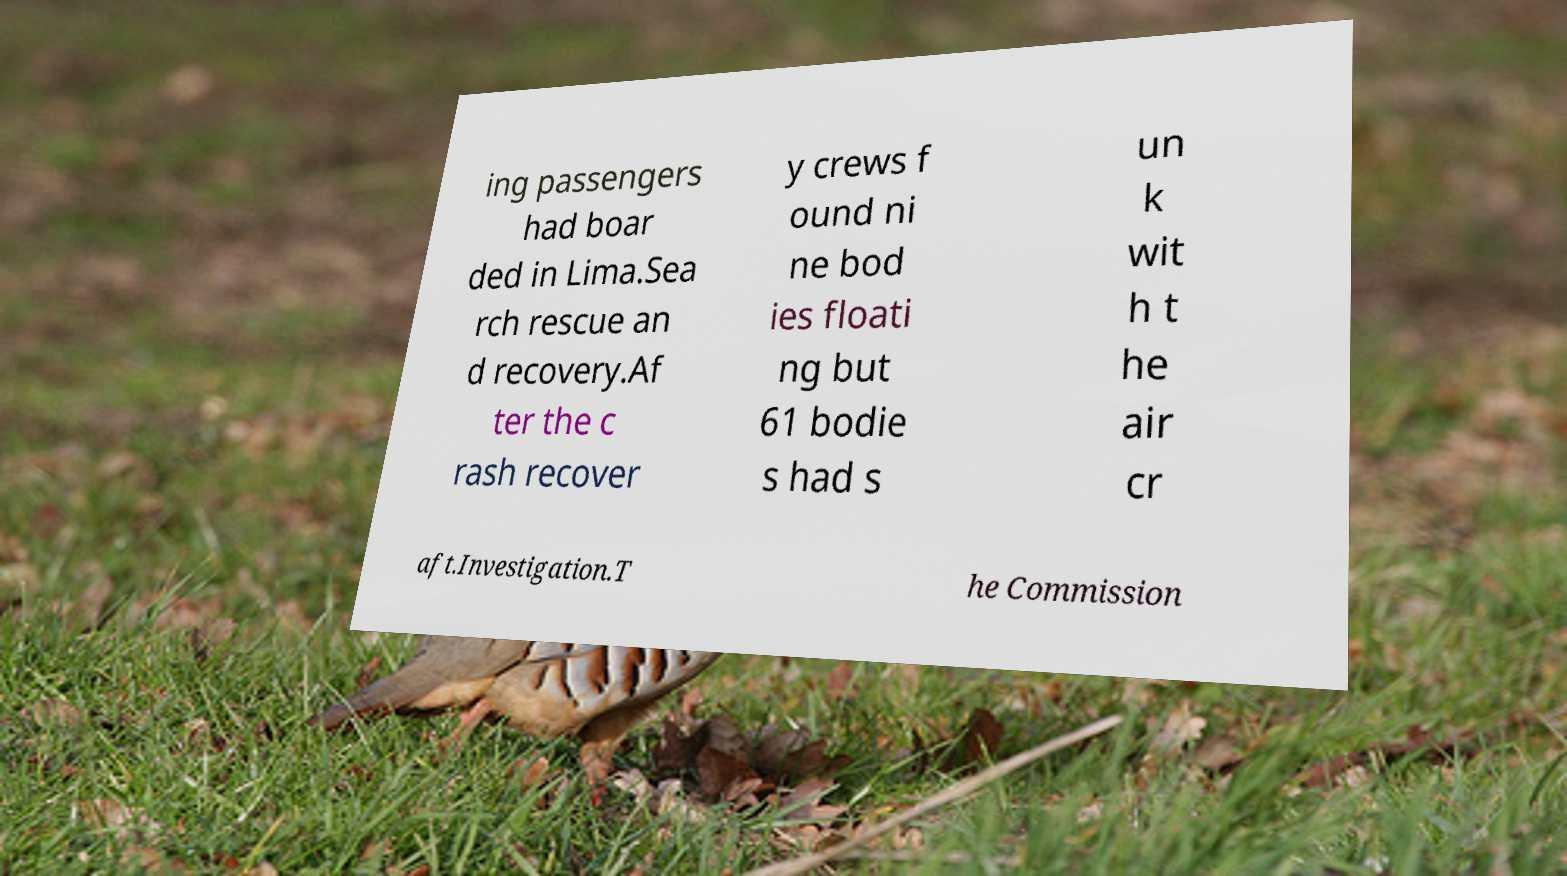I need the written content from this picture converted into text. Can you do that? ing passengers had boar ded in Lima.Sea rch rescue an d recovery.Af ter the c rash recover y crews f ound ni ne bod ies floati ng but 61 bodie s had s un k wit h t he air cr aft.Investigation.T he Commission 